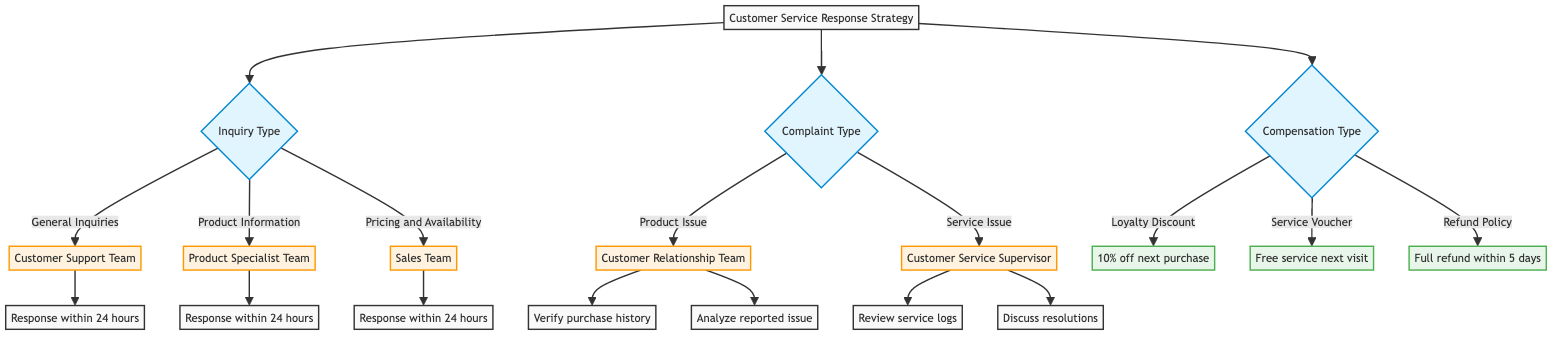What team handles General Inquiries? The diagram specifies that General Inquiries are handled by the Customer Support Team. This can be traced from the inquiry type section where General Inquiries directly leads to the Customer Support Team node.
Answer: Customer Support Team What is the standard response time for Pricing and Availability inquiries? According to the diagram, the standard response time for Pricing and Availability inquiries is stated as "Within 24 hours." This information is found under the Pricing and Availability node in the inquiry section.
Answer: Within 24 hours Which team is responsible for Product Issues? The diagram indicates that the Customer Relationship Team is responsible for handling Product Issues. This can be followed from the Complaints section, where Product Issue leads directly to the Customer Relationship Team node.
Answer: Customer Relationship Team What type of compensation is offered for verified complaints and frequent customers? The diagram specifies that a Loyalty Discount is offered in this case, defined under the Compensation Offers section, illustrating the criteria and the corresponding discount rate.
Answer: Loyalty Discount What steps are involved in verifying a Product Issue? The diagram outlines three verification steps for a Product Issue: request detailed information about the issue, verify the purchase history, and analyze the reported issue. These steps are clearly listed under the handling of a Product Issue.
Answer: Request detailed information about the issue, verify the purchase history, analyze the reported issue How many different compensation types are offered? The diagram shows three types of compensation: Loyalty Discount, Service Voucher, and Refund Policy. These types are listed under the Compensation Offers section in the diagram, counting directly leads to the total.
Answer: 3 What message is sent to a customer receiving a service voucher? According to the Compensation Offers section in the diagram, the message template for a service voucher states, "We apologize for the inconvenience caused. Please accept this voucher for a complimentary service on your next visit." This provides the exact response when a service voucher is offered.
Answer: We apologize for the inconvenience caused. Please accept this voucher for a complimentary service on your next visit What is the corrective action for a Service Issue? The diagram details that as a resolution for a Service Issue, one of the corrective actions could be taken is "We have taken corrective action to address the issue and ensure it doesn't reoccur." This information is retrieved from the response templates associated with Service Issue handling.
Answer: We have taken corrective action to address the issue and ensure it doesn't reoccur What is the eligibility criteria for a Refund Policy? The diagram states that the eligibility criteria for a Refund Policy includes having a verified product issue and no suitable replacement. This is specifically mentioned in the Compensation Offers section related to Refund Policy.
Answer: Verified product issue and no suitable replacement 